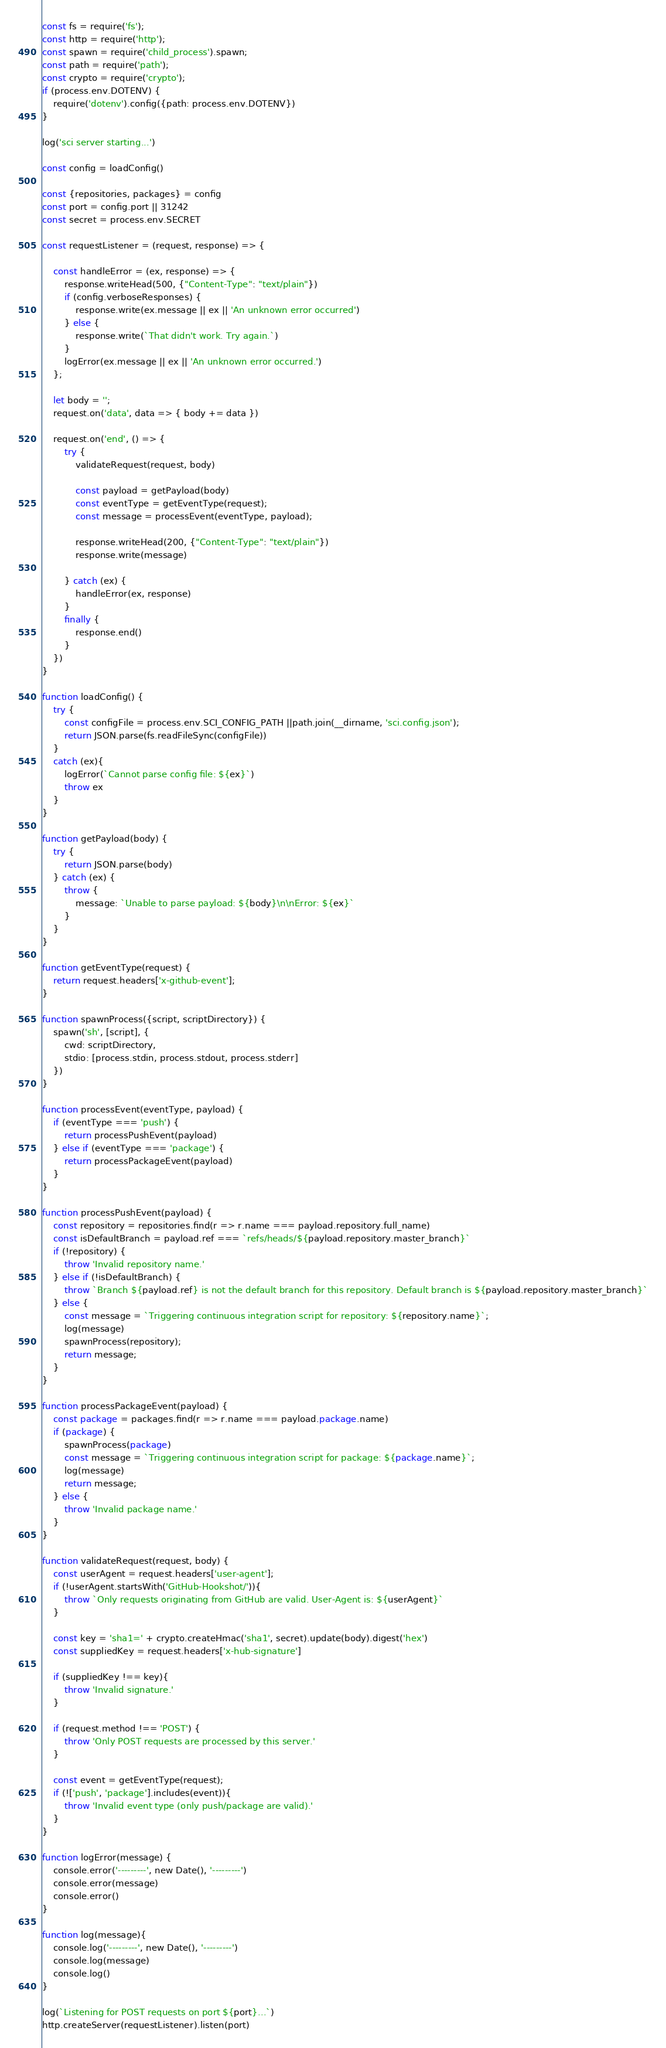<code> <loc_0><loc_0><loc_500><loc_500><_JavaScript_>const fs = require('fs');
const http = require('http');
const spawn = require('child_process').spawn;
const path = require('path');
const crypto = require('crypto');
if (process.env.DOTENV) {
    require('dotenv').config({path: process.env.DOTENV})
}

log('sci server starting...')

const config = loadConfig()

const {repositories, packages} = config
const port = config.port || 31242
const secret = process.env.SECRET

const requestListener = (request, response) => {

    const handleError = (ex, response) => {
        response.writeHead(500, {"Content-Type": "text/plain"})
        if (config.verboseResponses) {
            response.write(ex.message || ex || 'An unknown error occurred')
        } else {
            response.write(`That didn't work. Try again.`)
        }
        logError(ex.message || ex || 'An unknown error occurred.')
    };

    let body = '';
    request.on('data', data => { body += data })
    
    request.on('end', () => {
        try {
            validateRequest(request, body)

            const payload = getPayload(body)
            const eventType = getEventType(request);
            const message = processEvent(eventType, payload);

            response.writeHead(200, {"Content-Type": "text/plain"})
            response.write(message)

        } catch (ex) {                                        
            handleError(ex, response)                    
        }                     
        finally {                    
            response.end()
        }                                                          
    })            
}

function loadConfig() {
    try {
        const configFile = process.env.SCI_CONFIG_PATH ||path.join(__dirname, 'sci.config.json');
        return JSON.parse(fs.readFileSync(configFile))
    }
    catch (ex){
        logError(`Cannot parse config file: ${ex}`)
        throw ex
    }
}

function getPayload(body) {
    try {
        return JSON.parse(body)
    } catch (ex) {
        throw {
            message: `Unable to parse payload: ${body}\n\nError: ${ex}`
        }
    }
}

function getEventType(request) {
    return request.headers['x-github-event'];
}

function spawnProcess({script, scriptDirectory}) {
    spawn('sh', [script], {
        cwd: scriptDirectory,
        stdio: [process.stdin, process.stdout, process.stderr]
    })
}

function processEvent(eventType, payload) {
    if (eventType === 'push') {
        return processPushEvent(payload)
    } else if (eventType === 'package') {
        return processPackageEvent(payload)
    }
}

function processPushEvent(payload) {
    const repository = repositories.find(r => r.name === payload.repository.full_name)
    const isDefaultBranch = payload.ref === `refs/heads/${payload.repository.master_branch}`
    if (!repository) {
        throw 'Invalid repository name.'
    } else if (!isDefaultBranch) {
        throw `Branch ${payload.ref} is not the default branch for this repository. Default branch is ${payload.repository.master_branch}`
    } else {
        const message = `Triggering continuous integration script for repository: ${repository.name}`;
        log(message)
        spawnProcess(repository);
        return message;
    }
}

function processPackageEvent(payload) {
    const package = packages.find(r => r.name === payload.package.name)
    if (package) {
        spawnProcess(package)
        const message = `Triggering continuous integration script for package: ${package.name}`;
        log(message)
        return message;
    } else {
        throw 'Invalid package name.'
    }
}

function validateRequest(request, body) {
    const userAgent = request.headers['user-agent'];
    if (!userAgent.startsWith('GitHub-Hookshot/')){
        throw `Only requests originating from GitHub are valid. User-Agent is: ${userAgent}`
    }

    const key = 'sha1=' + crypto.createHmac('sha1', secret).update(body).digest('hex')
    const suppliedKey = request.headers['x-hub-signature']

    if (suppliedKey !== key){
        throw 'Invalid signature.'
    }

    if (request.method !== 'POST') {
        throw 'Only POST requests are processed by this server.'
    }

    const event = getEventType(request);
    if (!['push', 'package'].includes(event)){
        throw 'Invalid event type (only push/package are valid).'
    }
}

function logError(message) {
    console.error('---------', new Date(), '---------')
    console.error(message)
    console.error()
}

function log(message){
    console.log('---------', new Date(), '---------')
    console.log(message)
    console.log()
}

log(`Listening for POST requests on port ${port}...`)
http.createServer(requestListener).listen(port)
</code> 